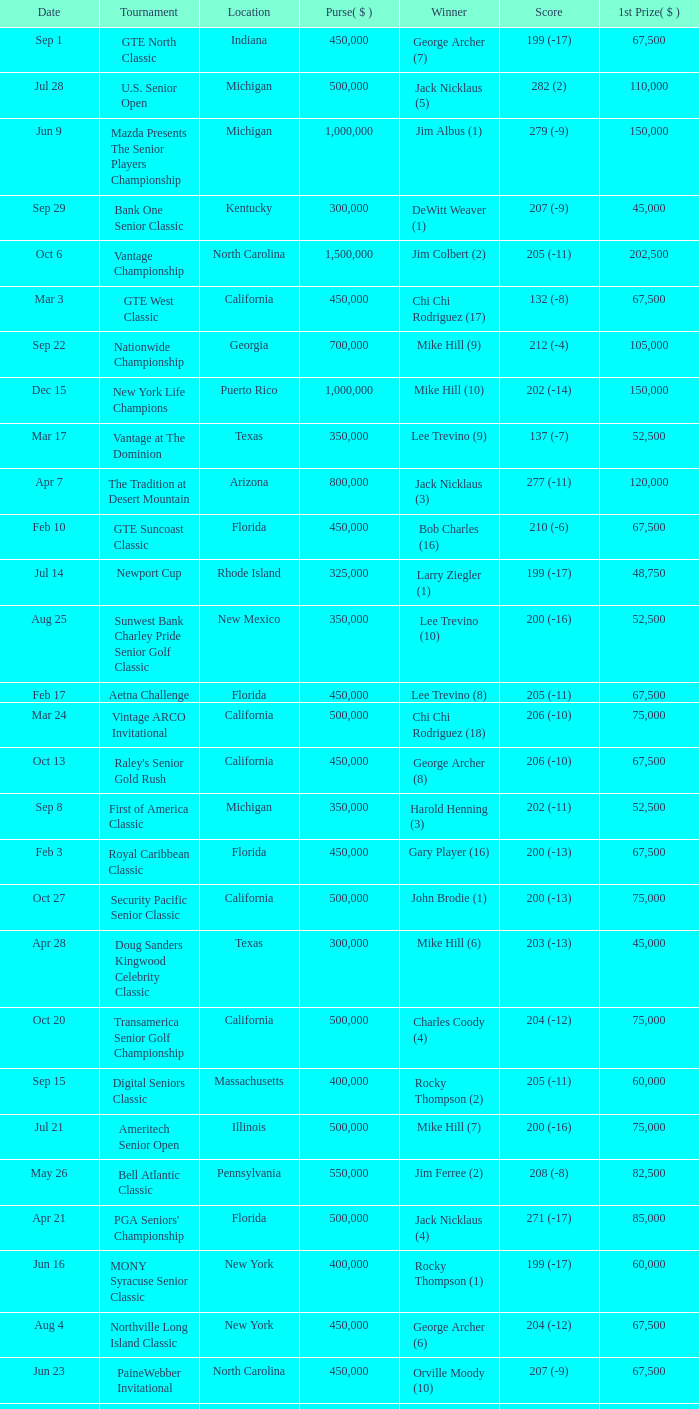Where was the security pacific senior classic? California. 